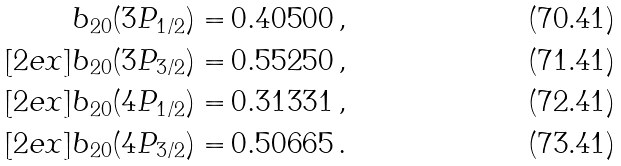<formula> <loc_0><loc_0><loc_500><loc_500>b _ { 2 0 } ( 3 P _ { 1 / 2 } ) = & \, 0 . 4 0 5 0 0 \, , \\ [ 2 e x ] b _ { 2 0 } ( 3 P _ { 3 / 2 } ) = & \, 0 . 5 5 2 5 0 \, , \\ [ 2 e x ] b _ { 2 0 } ( 4 P _ { 1 / 2 } ) = & \, 0 . 3 1 3 3 1 \, , \\ [ 2 e x ] b _ { 2 0 } ( 4 P _ { 3 / 2 } ) = & \, 0 . 5 0 6 6 5 \, .</formula> 